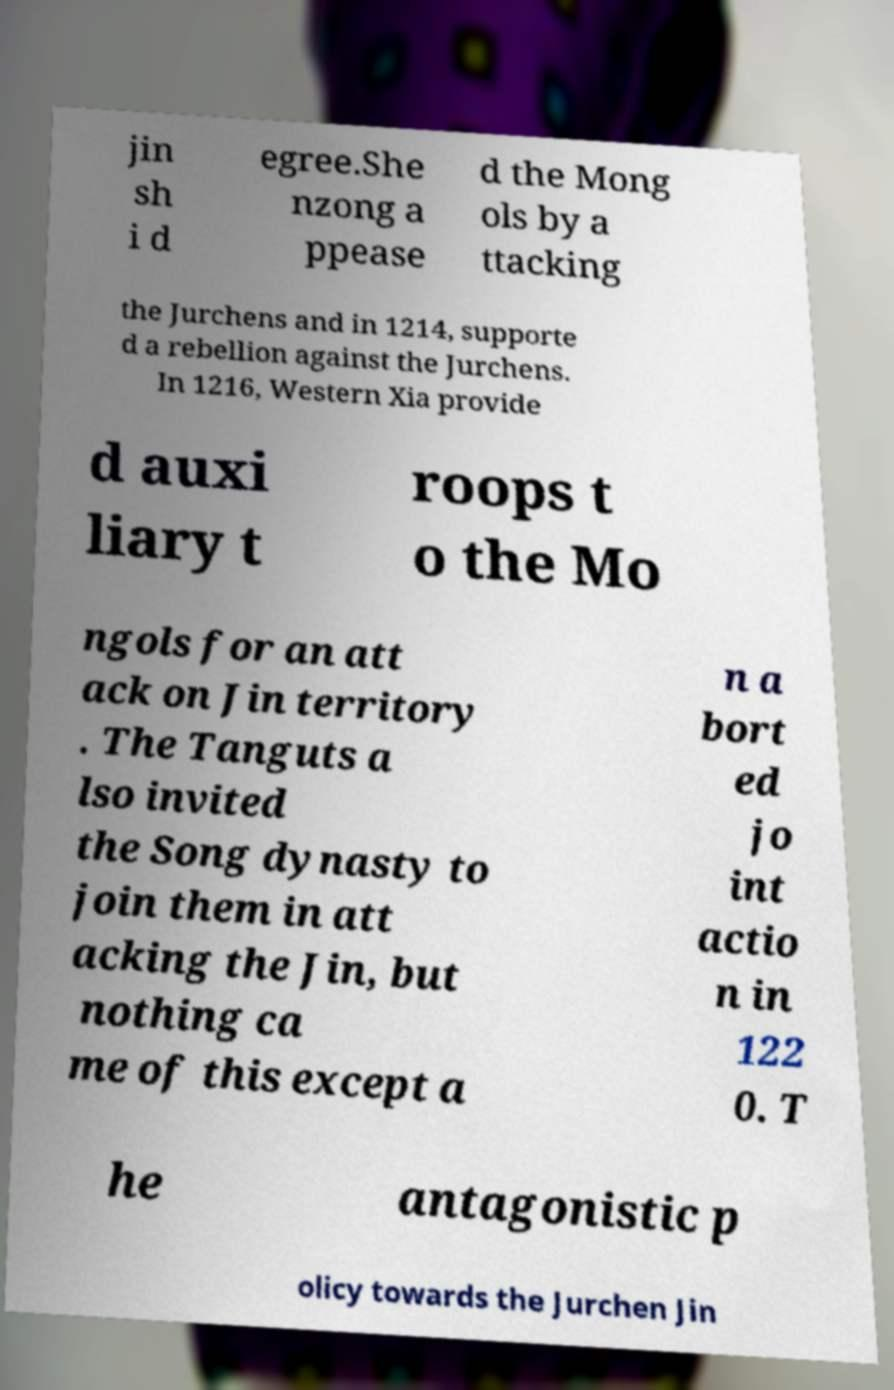Please identify and transcribe the text found in this image. jin sh i d egree.She nzong a ppease d the Mong ols by a ttacking the Jurchens and in 1214, supporte d a rebellion against the Jurchens. In 1216, Western Xia provide d auxi liary t roops t o the Mo ngols for an att ack on Jin territory . The Tanguts a lso invited the Song dynasty to join them in att acking the Jin, but nothing ca me of this except a n a bort ed jo int actio n in 122 0. T he antagonistic p olicy towards the Jurchen Jin 